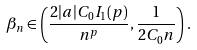Convert formula to latex. <formula><loc_0><loc_0><loc_500><loc_500>\beta _ { n } \in \left ( \frac { 2 | a | C _ { 0 } I _ { 1 } ( p ) } { n ^ { p } } , \frac { 1 } { 2 C _ { 0 } n } \right ) .</formula> 